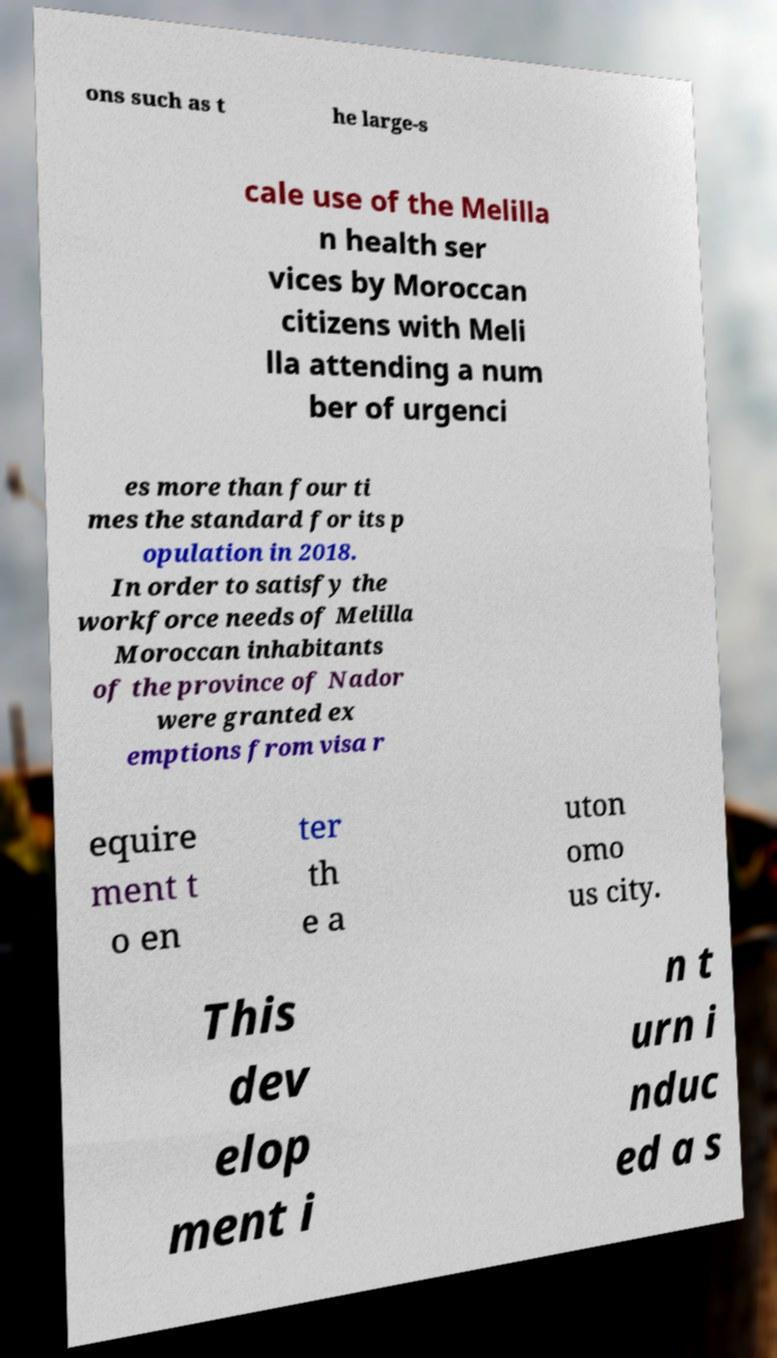Please identify and transcribe the text found in this image. ons such as t he large-s cale use of the Melilla n health ser vices by Moroccan citizens with Meli lla attending a num ber of urgenci es more than four ti mes the standard for its p opulation in 2018. In order to satisfy the workforce needs of Melilla Moroccan inhabitants of the province of Nador were granted ex emptions from visa r equire ment t o en ter th e a uton omo us city. This dev elop ment i n t urn i nduc ed a s 